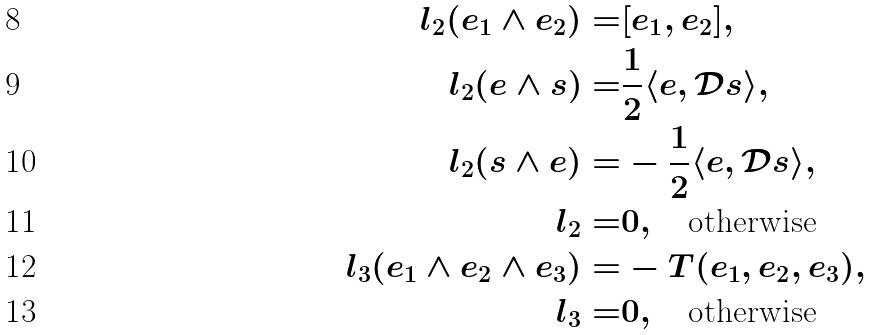<formula> <loc_0><loc_0><loc_500><loc_500>l _ { 2 } ( e _ { 1 } \wedge e _ { 2 } ) = & [ e _ { 1 } , e _ { 2 } ] , \\ l _ { 2 } ( e \wedge s ) = & \frac { 1 } { 2 } \langle e , \mathcal { D } s \rangle , \\ l _ { 2 } ( s \wedge e ) = & - \frac { 1 } { 2 } \langle e , \mathcal { D } s \rangle , \\ l _ { 2 } = & 0 , \quad \text {otherwise} \\ l _ { 3 } ( e _ { 1 } \wedge e _ { 2 } \wedge e _ { 3 } ) = & - T ( e _ { 1 } , e _ { 2 } , e _ { 3 } ) , \\ l _ { 3 } = & 0 , \quad \text {otherwise}</formula> 